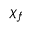Convert formula to latex. <formula><loc_0><loc_0><loc_500><loc_500>\chi _ { f }</formula> 